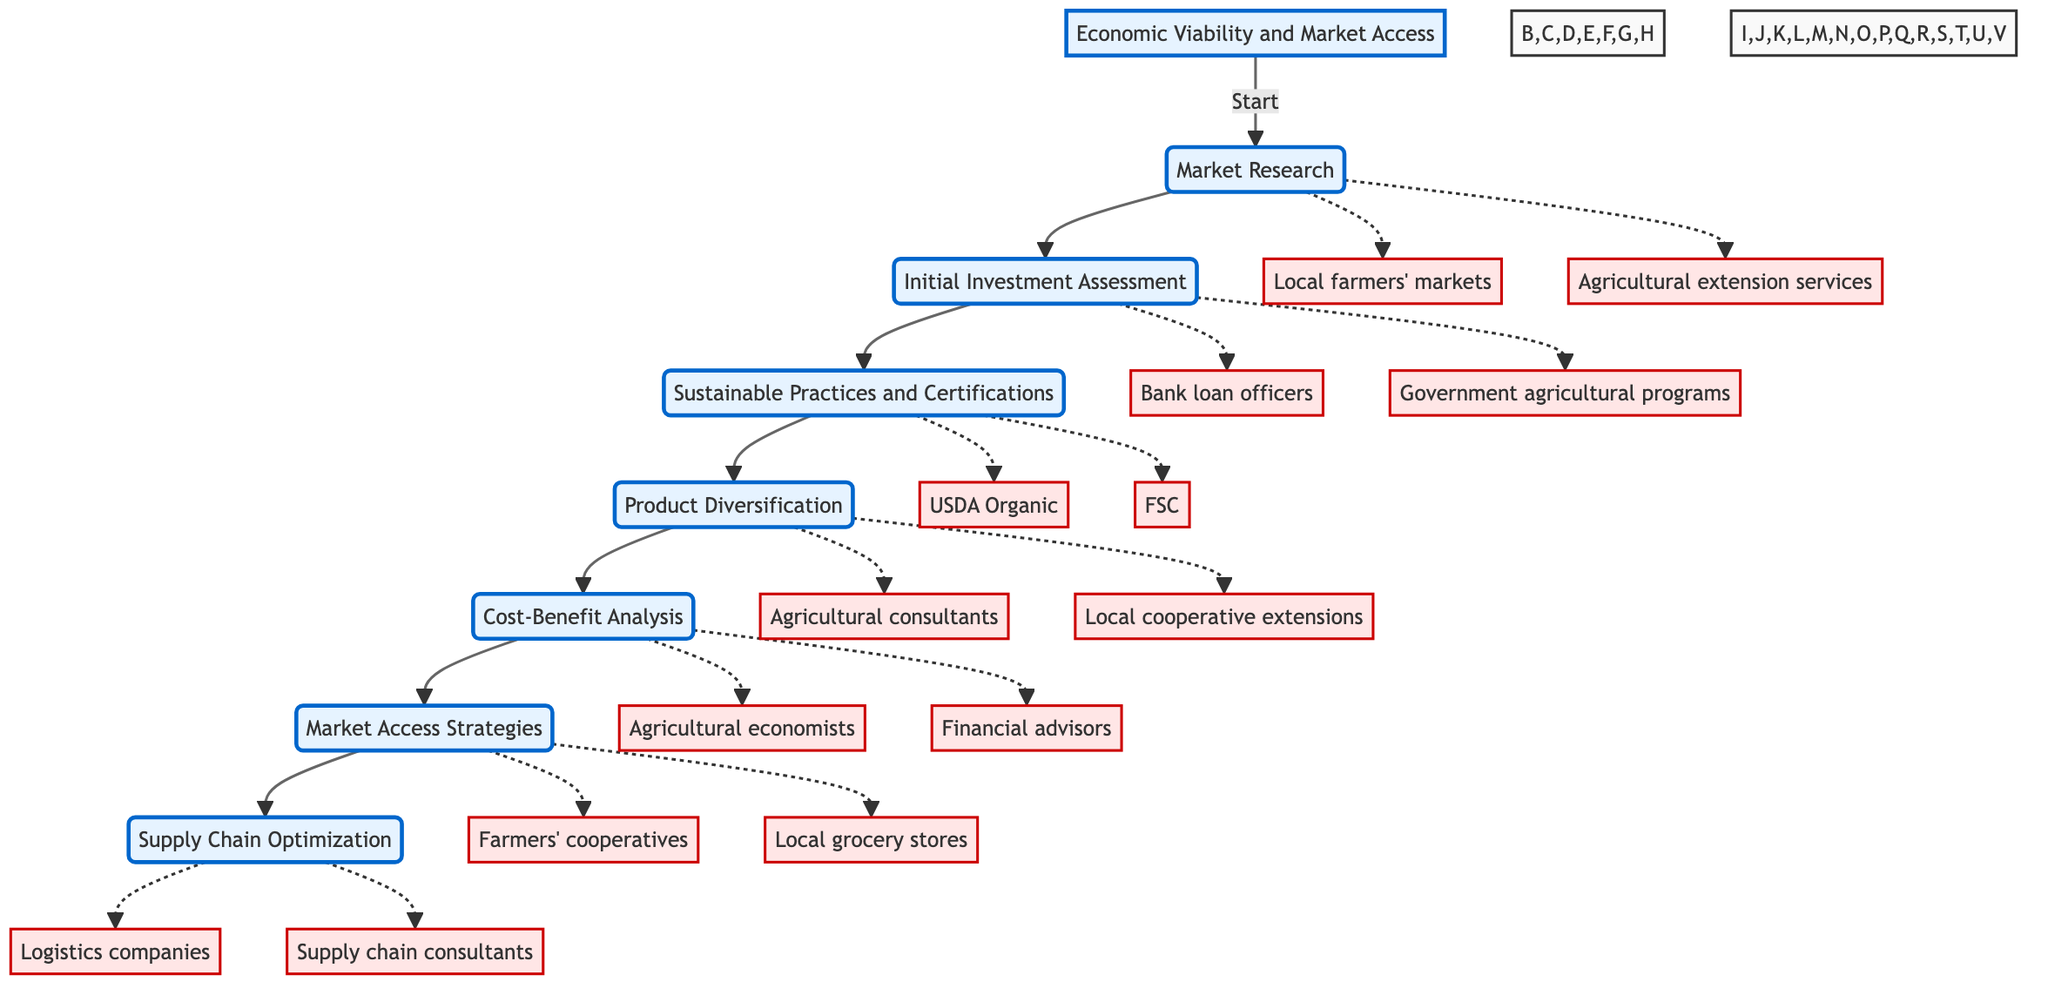What is the starting point of the diagram? The starting point is labeled "Economic Viability and Market Access," which is the top node from which all other processes branch out.
Answer: Economic Viability and Market Access How many main activities are there in the diagram? The main activities, represented as nodes, are Market Research, Initial Investment Assessment, Sustainable Practices and Certifications, Product Diversification, Cost-Benefit Analysis, Market Access Strategies, and Supply Chain Optimization, totaling seven activities.
Answer: 7 Which activity follows Market Research? The diagram shows that after Market Research, the next activity is Initial Investment Assessment, indicated by a direct arrow leading to it.
Answer: Initial Investment Assessment Which entities are related to Sustainable Practices and Certifications? The entities related to Sustainable Practices and Certifications, as indicated by the dashed lines, include USDA Organic and FSC (Forest Stewardship Council).
Answer: USDA Organic, FSC In what phase does Cost-Benefit Analysis occur? Cost-Benefit Analysis is part of the main phase and follows the activity of Product Diversification, reflected by the sequential arrangement in the diagram.
Answer: Phase What two entities are associated with Market Access Strategies? According to the diagram, the entities associated with Market Access Strategies are Farmers' cooperatives and Local grocery stores, as shown by the dashed lines pointing towards them.
Answer: Farmers' cooperatives, Local grocery stores Which activity should be completed before exploring Product Diversification? The diagram illustrates that before exploring Product Diversification, the activity of Sustainable Practices and Certifications must be completed, as indicated by the flow direction.
Answer: Sustainable Practices and Certifications What is the last activity in the Clinical Pathway? The last activity in the pathway is Supply Chain Optimization, as it is the final node connected at the end of the sequence in the diagram.
Answer: Supply Chain Optimization Which two activities are directly connected by a flow direction? The diagram shows a direct connection from Initial Investment Assessment to Sustainable Practices and Certifications, indicating a sequential relationship between these two activities.
Answer: Initial Investment Assessment, Sustainable Practices and Certifications 